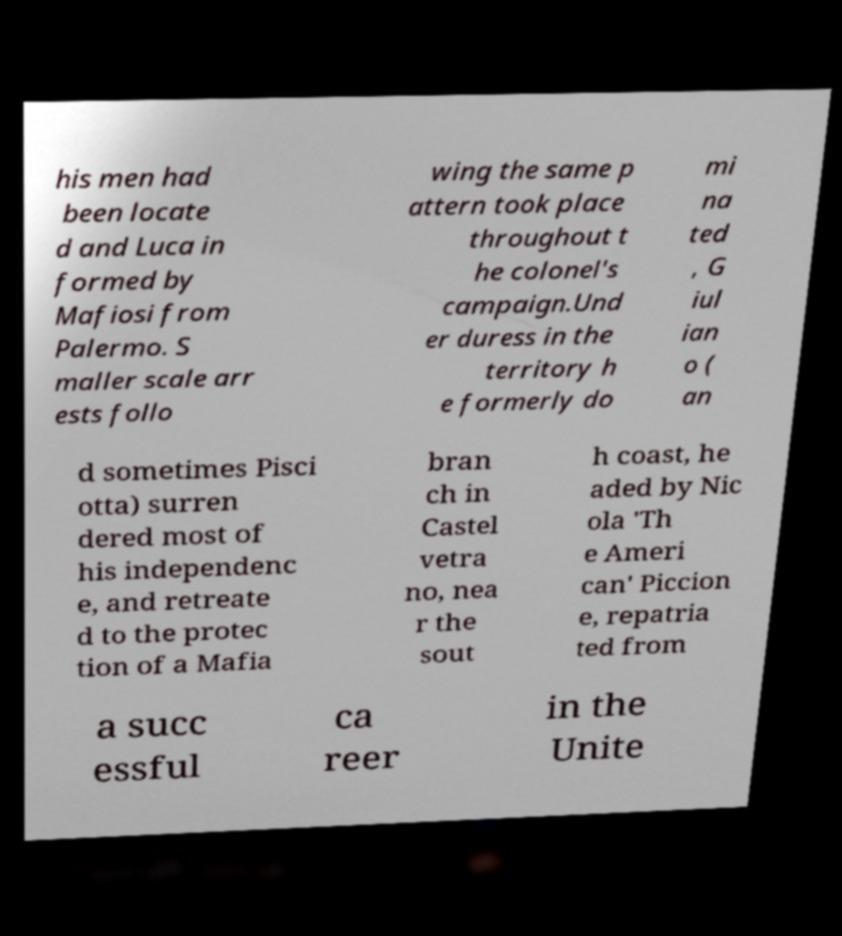Could you extract and type out the text from this image? his men had been locate d and Luca in formed by Mafiosi from Palermo. S maller scale arr ests follo wing the same p attern took place throughout t he colonel's campaign.Und er duress in the territory h e formerly do mi na ted , G iul ian o ( an d sometimes Pisci otta) surren dered most of his independenc e, and retreate d to the protec tion of a Mafia bran ch in Castel vetra no, nea r the sout h coast, he aded by Nic ola 'Th e Ameri can' Piccion e, repatria ted from a succ essful ca reer in the Unite 